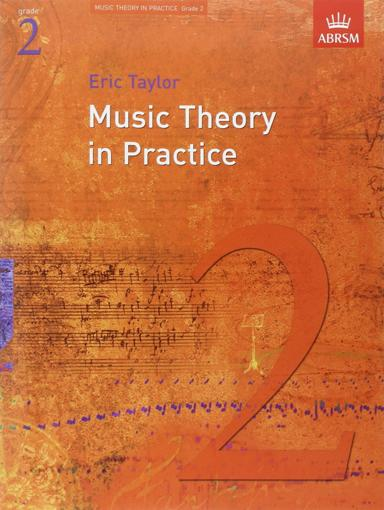What is the title of the book in the image? The title of the book shown in the image is "Music Theory in Practice, Grade 2," authored by Eric Taylor, and it is specifically designed to help students prepare for their ABRSM music theory exams. 